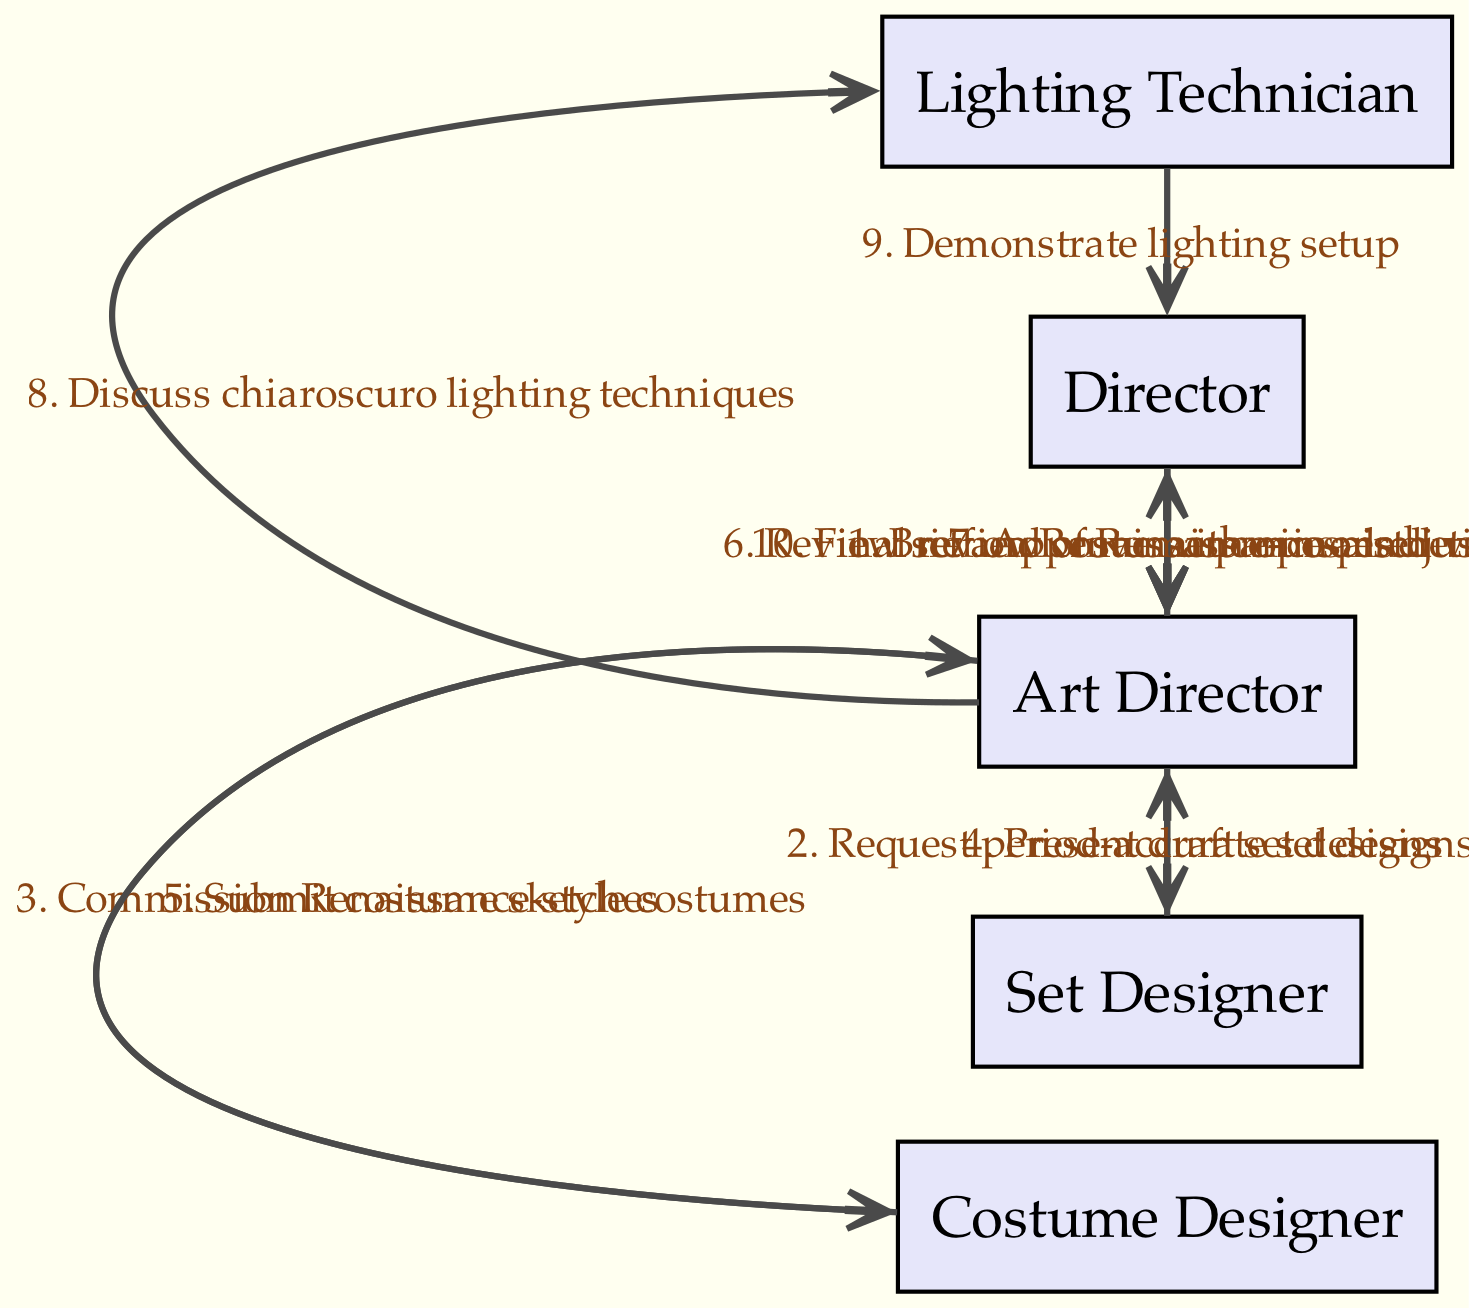What is the first message from the Director? The first message from the Director is to the Art Director, where they provide a brief about their Renaissance-inspired vision.
Answer: Brief on Renaissance-inspired vision How many nodes are in this sequence diagram? The diagram contains five unique actors: Director, Art Director, Set Designer, Costume Designer, and Lighting Technician, resulting in a total of five nodes.
Answer: 5 Who receives the request for period-accurate set designs? The Art Director receives the request for period-accurate set designs from the Director.
Answer: Set Designer Which actor presents draft set designs? The Set Designer is the actor who presents the draft set designs.
Answer: Set Designer What is the last action taken by the Director? The last action taken by the Director is to conduct a final review of Renaissance aesthetics.
Answer: Final review of Renaissance aesthetics What is the relationship between the Art Director and the Costume Designer? The relationship involves the Art Director commissioning Renaissance-style costumes from the Costume Designer.
Answer: Commission Renaissance-style costumes How many messages are exchanged in total? There are ten messages exchanged in the diagram among the actors, each representing a step in the collaborative workflow.
Answer: 10 Which actor is involved in discussing chiaroscuro lighting techniques? The Lighting Technician discusses chiaroscuro lighting techniques with the Art Director.
Answer: Lighting Technician What message follows the submission of costume sketches? The message that follows is from the Art Director to the Director, reviewing set and costume proposals.
Answer: Review set and costume proposals 